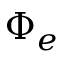Convert formula to latex. <formula><loc_0><loc_0><loc_500><loc_500>\Phi _ { e }</formula> 